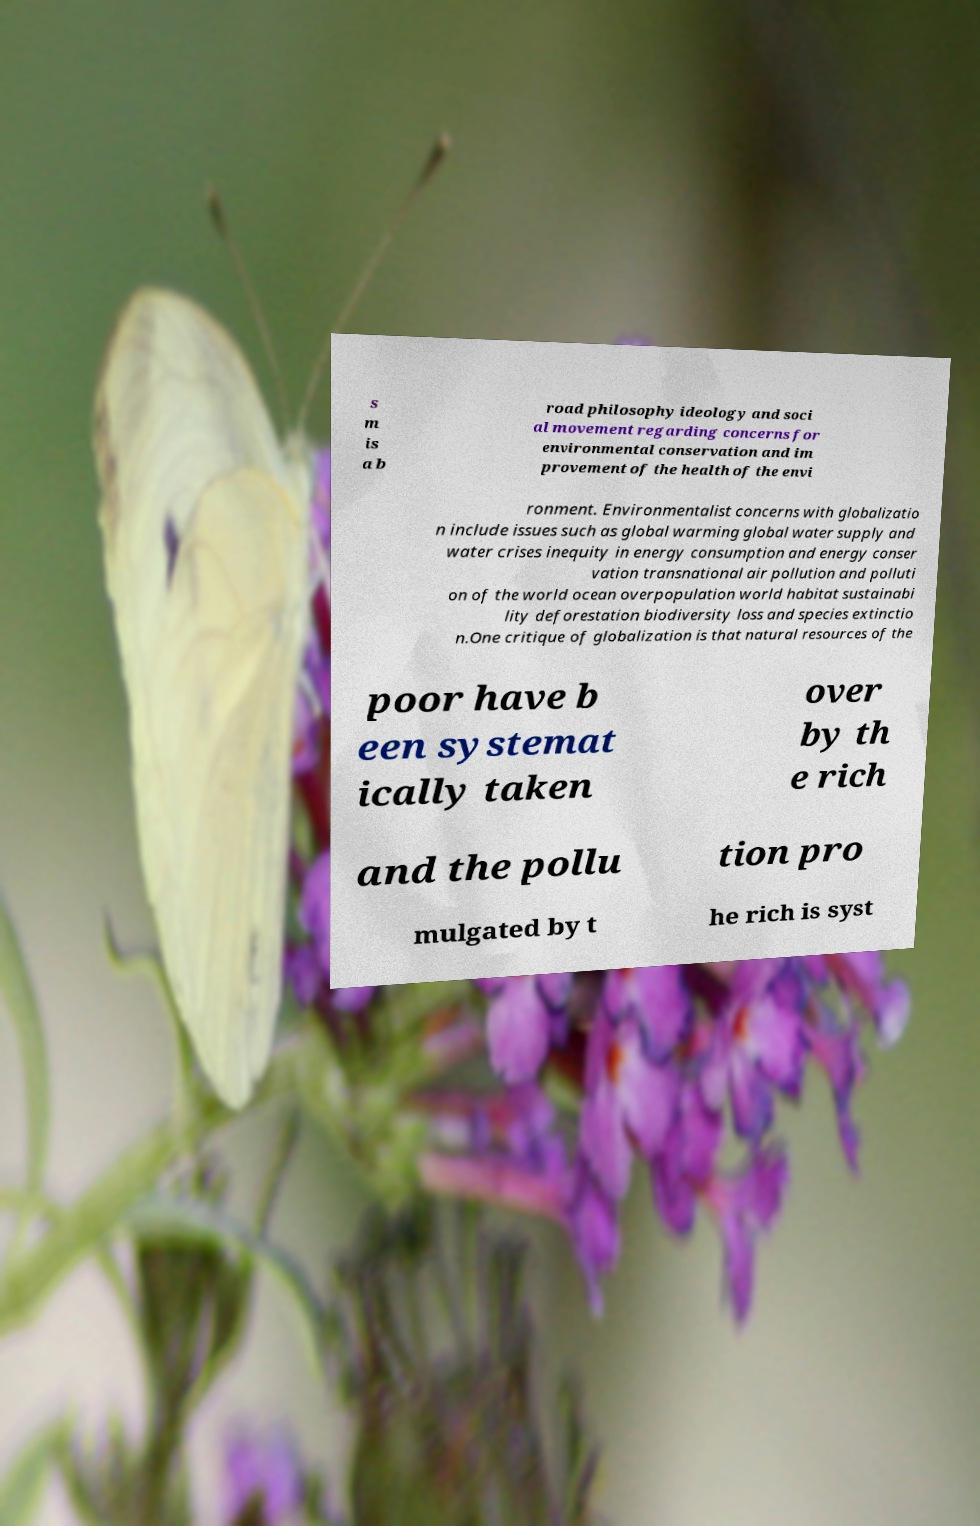For documentation purposes, I need the text within this image transcribed. Could you provide that? s m is a b road philosophy ideology and soci al movement regarding concerns for environmental conservation and im provement of the health of the envi ronment. Environmentalist concerns with globalizatio n include issues such as global warming global water supply and water crises inequity in energy consumption and energy conser vation transnational air pollution and polluti on of the world ocean overpopulation world habitat sustainabi lity deforestation biodiversity loss and species extinctio n.One critique of globalization is that natural resources of the poor have b een systemat ically taken over by th e rich and the pollu tion pro mulgated by t he rich is syst 